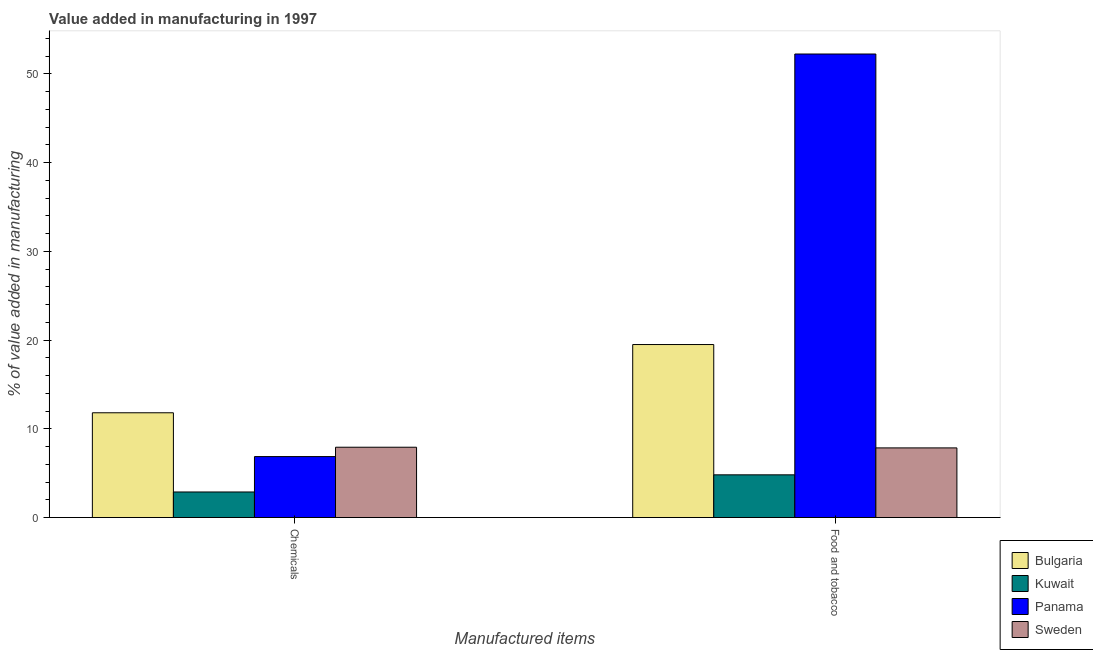How many different coloured bars are there?
Offer a very short reply. 4. How many groups of bars are there?
Keep it short and to the point. 2. Are the number of bars per tick equal to the number of legend labels?
Provide a succinct answer. Yes. Are the number of bars on each tick of the X-axis equal?
Your response must be concise. Yes. How many bars are there on the 1st tick from the left?
Provide a succinct answer. 4. What is the label of the 1st group of bars from the left?
Make the answer very short. Chemicals. What is the value added by  manufacturing chemicals in Bulgaria?
Your answer should be compact. 11.81. Across all countries, what is the maximum value added by  manufacturing chemicals?
Your response must be concise. 11.81. Across all countries, what is the minimum value added by manufacturing food and tobacco?
Your response must be concise. 4.81. In which country was the value added by  manufacturing chemicals maximum?
Provide a succinct answer. Bulgaria. In which country was the value added by manufacturing food and tobacco minimum?
Offer a terse response. Kuwait. What is the total value added by  manufacturing chemicals in the graph?
Keep it short and to the point. 29.49. What is the difference between the value added by manufacturing food and tobacco in Panama and that in Bulgaria?
Your answer should be very brief. 32.74. What is the difference between the value added by manufacturing food and tobacco in Kuwait and the value added by  manufacturing chemicals in Sweden?
Make the answer very short. -3.11. What is the average value added by  manufacturing chemicals per country?
Your response must be concise. 7.37. What is the difference between the value added by  manufacturing chemicals and value added by manufacturing food and tobacco in Bulgaria?
Give a very brief answer. -7.69. What is the ratio of the value added by  manufacturing chemicals in Kuwait to that in Bulgaria?
Offer a terse response. 0.24. What does the 3rd bar from the left in Chemicals represents?
Ensure brevity in your answer.  Panama. What does the 3rd bar from the right in Food and tobacco represents?
Your response must be concise. Kuwait. How many bars are there?
Ensure brevity in your answer.  8. Are all the bars in the graph horizontal?
Make the answer very short. No. What is the difference between two consecutive major ticks on the Y-axis?
Your answer should be very brief. 10. Are the values on the major ticks of Y-axis written in scientific E-notation?
Offer a terse response. No. How are the legend labels stacked?
Keep it short and to the point. Vertical. What is the title of the graph?
Make the answer very short. Value added in manufacturing in 1997. What is the label or title of the X-axis?
Keep it short and to the point. Manufactured items. What is the label or title of the Y-axis?
Your answer should be very brief. % of value added in manufacturing. What is the % of value added in manufacturing in Bulgaria in Chemicals?
Offer a very short reply. 11.81. What is the % of value added in manufacturing in Kuwait in Chemicals?
Your response must be concise. 2.88. What is the % of value added in manufacturing of Panama in Chemicals?
Keep it short and to the point. 6.87. What is the % of value added in manufacturing in Sweden in Chemicals?
Your answer should be compact. 7.93. What is the % of value added in manufacturing of Bulgaria in Food and tobacco?
Offer a very short reply. 19.5. What is the % of value added in manufacturing of Kuwait in Food and tobacco?
Your response must be concise. 4.81. What is the % of value added in manufacturing of Panama in Food and tobacco?
Make the answer very short. 52.24. What is the % of value added in manufacturing in Sweden in Food and tobacco?
Your answer should be compact. 7.85. Across all Manufactured items, what is the maximum % of value added in manufacturing of Bulgaria?
Your answer should be very brief. 19.5. Across all Manufactured items, what is the maximum % of value added in manufacturing of Kuwait?
Your response must be concise. 4.81. Across all Manufactured items, what is the maximum % of value added in manufacturing in Panama?
Your answer should be compact. 52.24. Across all Manufactured items, what is the maximum % of value added in manufacturing in Sweden?
Your response must be concise. 7.93. Across all Manufactured items, what is the minimum % of value added in manufacturing in Bulgaria?
Your response must be concise. 11.81. Across all Manufactured items, what is the minimum % of value added in manufacturing in Kuwait?
Make the answer very short. 2.88. Across all Manufactured items, what is the minimum % of value added in manufacturing in Panama?
Give a very brief answer. 6.87. Across all Manufactured items, what is the minimum % of value added in manufacturing in Sweden?
Make the answer very short. 7.85. What is the total % of value added in manufacturing of Bulgaria in the graph?
Provide a succinct answer. 31.31. What is the total % of value added in manufacturing of Kuwait in the graph?
Make the answer very short. 7.7. What is the total % of value added in manufacturing in Panama in the graph?
Keep it short and to the point. 59.11. What is the total % of value added in manufacturing of Sweden in the graph?
Your answer should be very brief. 15.77. What is the difference between the % of value added in manufacturing in Bulgaria in Chemicals and that in Food and tobacco?
Give a very brief answer. -7.69. What is the difference between the % of value added in manufacturing of Kuwait in Chemicals and that in Food and tobacco?
Your response must be concise. -1.93. What is the difference between the % of value added in manufacturing of Panama in Chemicals and that in Food and tobacco?
Your answer should be very brief. -45.37. What is the difference between the % of value added in manufacturing in Sweden in Chemicals and that in Food and tobacco?
Offer a very short reply. 0.08. What is the difference between the % of value added in manufacturing of Bulgaria in Chemicals and the % of value added in manufacturing of Kuwait in Food and tobacco?
Your response must be concise. 6.99. What is the difference between the % of value added in manufacturing of Bulgaria in Chemicals and the % of value added in manufacturing of Panama in Food and tobacco?
Your answer should be compact. -40.43. What is the difference between the % of value added in manufacturing of Bulgaria in Chemicals and the % of value added in manufacturing of Sweden in Food and tobacco?
Offer a very short reply. 3.96. What is the difference between the % of value added in manufacturing of Kuwait in Chemicals and the % of value added in manufacturing of Panama in Food and tobacco?
Your answer should be compact. -49.35. What is the difference between the % of value added in manufacturing of Kuwait in Chemicals and the % of value added in manufacturing of Sweden in Food and tobacco?
Ensure brevity in your answer.  -4.97. What is the difference between the % of value added in manufacturing of Panama in Chemicals and the % of value added in manufacturing of Sweden in Food and tobacco?
Make the answer very short. -0.98. What is the average % of value added in manufacturing of Bulgaria per Manufactured items?
Provide a succinct answer. 15.65. What is the average % of value added in manufacturing of Kuwait per Manufactured items?
Offer a terse response. 3.85. What is the average % of value added in manufacturing of Panama per Manufactured items?
Offer a terse response. 29.55. What is the average % of value added in manufacturing in Sweden per Manufactured items?
Give a very brief answer. 7.89. What is the difference between the % of value added in manufacturing of Bulgaria and % of value added in manufacturing of Kuwait in Chemicals?
Your answer should be very brief. 8.93. What is the difference between the % of value added in manufacturing of Bulgaria and % of value added in manufacturing of Panama in Chemicals?
Your answer should be very brief. 4.94. What is the difference between the % of value added in manufacturing in Bulgaria and % of value added in manufacturing in Sweden in Chemicals?
Your answer should be very brief. 3.88. What is the difference between the % of value added in manufacturing in Kuwait and % of value added in manufacturing in Panama in Chemicals?
Offer a terse response. -3.99. What is the difference between the % of value added in manufacturing of Kuwait and % of value added in manufacturing of Sweden in Chemicals?
Offer a very short reply. -5.04. What is the difference between the % of value added in manufacturing in Panama and % of value added in manufacturing in Sweden in Chemicals?
Your answer should be very brief. -1.05. What is the difference between the % of value added in manufacturing in Bulgaria and % of value added in manufacturing in Kuwait in Food and tobacco?
Provide a short and direct response. 14.68. What is the difference between the % of value added in manufacturing of Bulgaria and % of value added in manufacturing of Panama in Food and tobacco?
Keep it short and to the point. -32.74. What is the difference between the % of value added in manufacturing of Bulgaria and % of value added in manufacturing of Sweden in Food and tobacco?
Your answer should be very brief. 11.65. What is the difference between the % of value added in manufacturing of Kuwait and % of value added in manufacturing of Panama in Food and tobacco?
Your answer should be very brief. -47.42. What is the difference between the % of value added in manufacturing in Kuwait and % of value added in manufacturing in Sweden in Food and tobacco?
Your answer should be compact. -3.03. What is the difference between the % of value added in manufacturing of Panama and % of value added in manufacturing of Sweden in Food and tobacco?
Ensure brevity in your answer.  44.39. What is the ratio of the % of value added in manufacturing of Bulgaria in Chemicals to that in Food and tobacco?
Make the answer very short. 0.61. What is the ratio of the % of value added in manufacturing of Kuwait in Chemicals to that in Food and tobacco?
Offer a terse response. 0.6. What is the ratio of the % of value added in manufacturing of Panama in Chemicals to that in Food and tobacco?
Ensure brevity in your answer.  0.13. What is the ratio of the % of value added in manufacturing of Sweden in Chemicals to that in Food and tobacco?
Provide a short and direct response. 1.01. What is the difference between the highest and the second highest % of value added in manufacturing of Bulgaria?
Keep it short and to the point. 7.69. What is the difference between the highest and the second highest % of value added in manufacturing in Kuwait?
Keep it short and to the point. 1.93. What is the difference between the highest and the second highest % of value added in manufacturing in Panama?
Make the answer very short. 45.37. What is the difference between the highest and the second highest % of value added in manufacturing in Sweden?
Give a very brief answer. 0.08. What is the difference between the highest and the lowest % of value added in manufacturing in Bulgaria?
Keep it short and to the point. 7.69. What is the difference between the highest and the lowest % of value added in manufacturing in Kuwait?
Provide a short and direct response. 1.93. What is the difference between the highest and the lowest % of value added in manufacturing of Panama?
Your answer should be very brief. 45.37. What is the difference between the highest and the lowest % of value added in manufacturing of Sweden?
Keep it short and to the point. 0.08. 